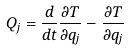Convert formula to latex. <formula><loc_0><loc_0><loc_500><loc_500>Q _ { j } = \frac { d } { d t } \frac { \partial T } { \partial \dot { q } _ { j } } - \frac { \partial T } { \partial q _ { j } }</formula> 